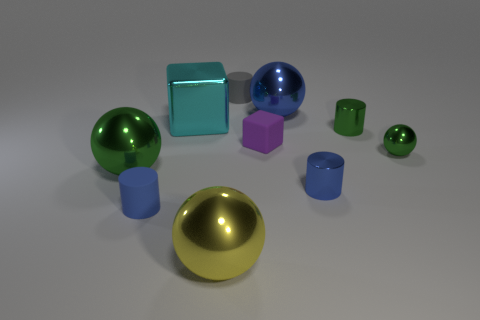How many other objects are there of the same material as the large cyan cube?
Offer a very short reply. 6. What number of big objects are the same color as the small block?
Give a very brief answer. 0. What size is the green metallic ball to the left of the small object that is on the left side of the tiny thing that is behind the large cyan block?
Ensure brevity in your answer.  Large. How many metallic objects are either tiny red blocks or purple cubes?
Offer a very short reply. 0. Is the shape of the cyan shiny thing the same as the purple object on the right side of the big cyan shiny cube?
Offer a very short reply. Yes. Are there more cubes that are left of the small gray matte object than small blue metal things that are left of the small cube?
Provide a succinct answer. Yes. Is there anything else that is the same color as the large metal cube?
Give a very brief answer. No. There is a large object on the right side of the tiny purple thing in front of the cyan block; is there a tiny cylinder that is in front of it?
Your answer should be compact. Yes. There is a tiny gray matte object to the left of the matte cube; is its shape the same as the small blue rubber object?
Ensure brevity in your answer.  Yes. Are there fewer big blue objects in front of the cyan block than gray objects in front of the gray matte cylinder?
Give a very brief answer. No. 